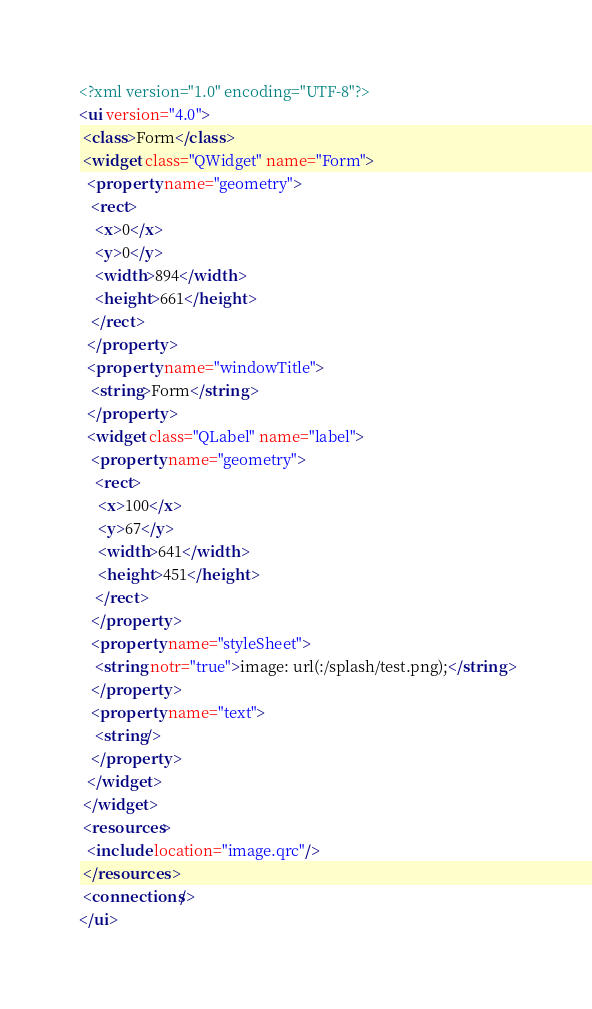Convert code to text. <code><loc_0><loc_0><loc_500><loc_500><_XML_><?xml version="1.0" encoding="UTF-8"?>
<ui version="4.0">
 <class>Form</class>
 <widget class="QWidget" name="Form">
  <property name="geometry">
   <rect>
    <x>0</x>
    <y>0</y>
    <width>894</width>
    <height>661</height>
   </rect>
  </property>
  <property name="windowTitle">
   <string>Form</string>
  </property>
  <widget class="QLabel" name="label">
   <property name="geometry">
    <rect>
     <x>100</x>
     <y>67</y>
     <width>641</width>
     <height>451</height>
    </rect>
   </property>
   <property name="styleSheet">
    <string notr="true">image: url(:/splash/test.png);</string>
   </property>
   <property name="text">
    <string/>
   </property>
  </widget>
 </widget>
 <resources>
  <include location="image.qrc"/>
 </resources>
 <connections/>
</ui>
</code> 